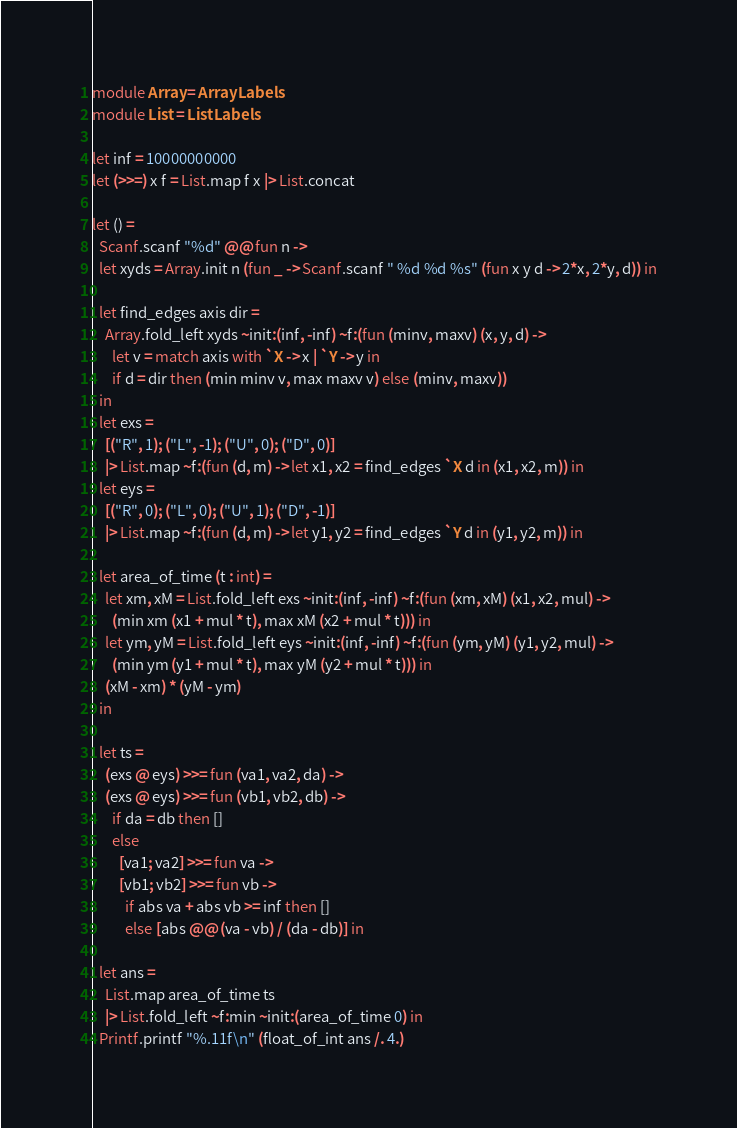Convert code to text. <code><loc_0><loc_0><loc_500><loc_500><_OCaml_>module Array = ArrayLabels
module List = ListLabels

let inf = 10000000000
let (>>=) x f = List.map f x |> List.concat

let () =
  Scanf.scanf "%d" @@ fun n ->
  let xyds = Array.init n (fun _ -> Scanf.scanf " %d %d %s" (fun x y d -> 2*x, 2*y, d)) in

  let find_edges axis dir =
    Array.fold_left xyds ~init:(inf, -inf) ~f:(fun (minv, maxv) (x, y, d) ->
      let v = match axis with `X -> x | `Y -> y in
      if d = dir then (min minv v, max maxv v) else (minv, maxv))
  in 
  let exs =
    [("R", 1); ("L", -1); ("U", 0); ("D", 0)]
    |> List.map ~f:(fun (d, m) -> let x1, x2 = find_edges `X d in (x1, x2, m)) in
  let eys =
    [("R", 0); ("L", 0); ("U", 1); ("D", -1)]
    |> List.map ~f:(fun (d, m) -> let y1, y2 = find_edges `Y d in (y1, y2, m)) in

  let area_of_time (t : int) =
    let xm, xM = List.fold_left exs ~init:(inf, -inf) ~f:(fun (xm, xM) (x1, x2, mul) ->
      (min xm (x1 + mul * t), max xM (x2 + mul * t))) in
    let ym, yM = List.fold_left eys ~init:(inf, -inf) ~f:(fun (ym, yM) (y1, y2, mul) ->
      (min ym (y1 + mul * t), max yM (y2 + mul * t))) in
    (xM - xm) * (yM - ym)
  in

  let ts =
    (exs @ eys) >>= fun (va1, va2, da) ->
    (exs @ eys) >>= fun (vb1, vb2, db) ->
      if da = db then []
      else
        [va1; va2] >>= fun va ->
        [vb1; vb2] >>= fun vb ->
          if abs va + abs vb >= inf then []
          else [abs @@ (va - vb) / (da - db)] in

  let ans =
    List.map area_of_time ts
    |> List.fold_left ~f:min ~init:(area_of_time 0) in
  Printf.printf "%.11f\n" (float_of_int ans /. 4.)
</code> 